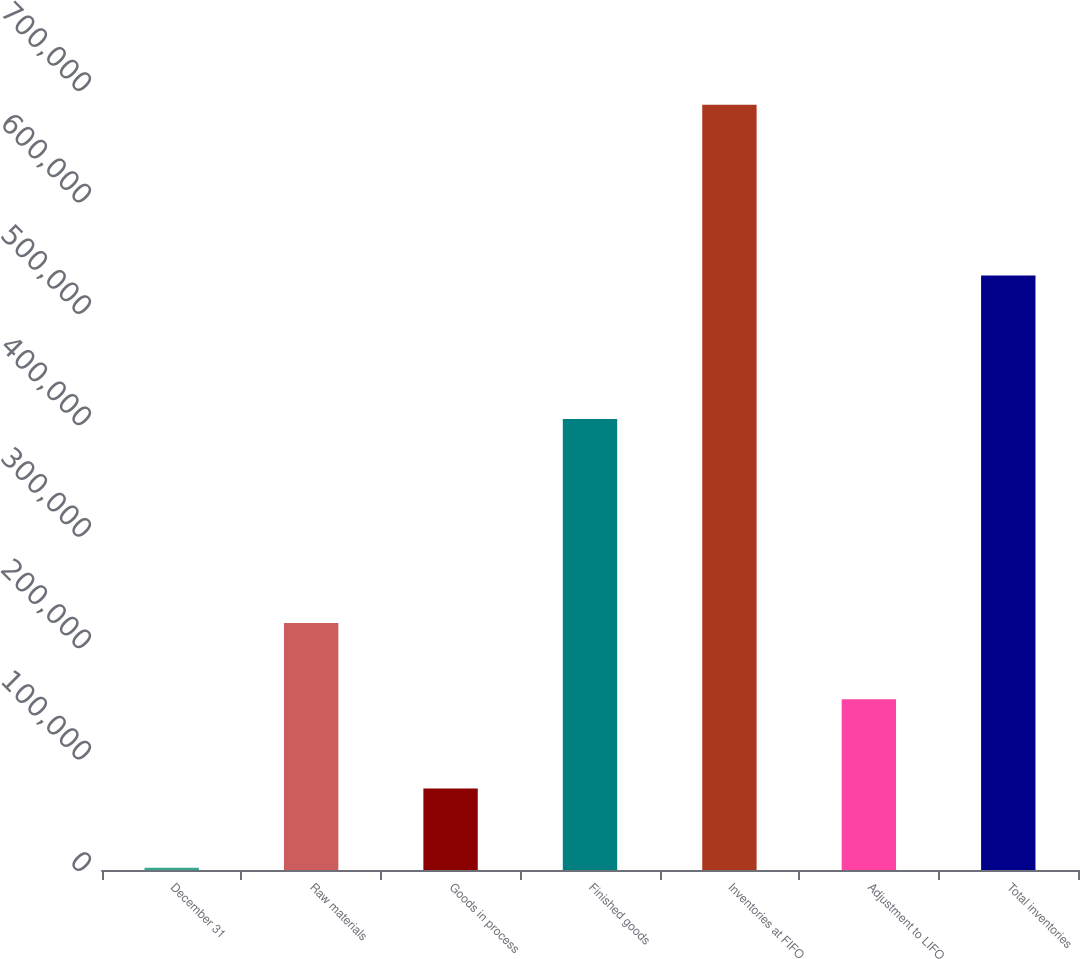Convert chart. <chart><loc_0><loc_0><loc_500><loc_500><bar_chart><fcel>December 31<fcel>Raw materials<fcel>Goods in process<fcel>Finished goods<fcel>Inventories at FIFO<fcel>Adjustment to LIFO<fcel>Total inventories<nl><fcel>2010<fcel>221648<fcel>73068<fcel>404666<fcel>686792<fcel>153170<fcel>533622<nl></chart> 